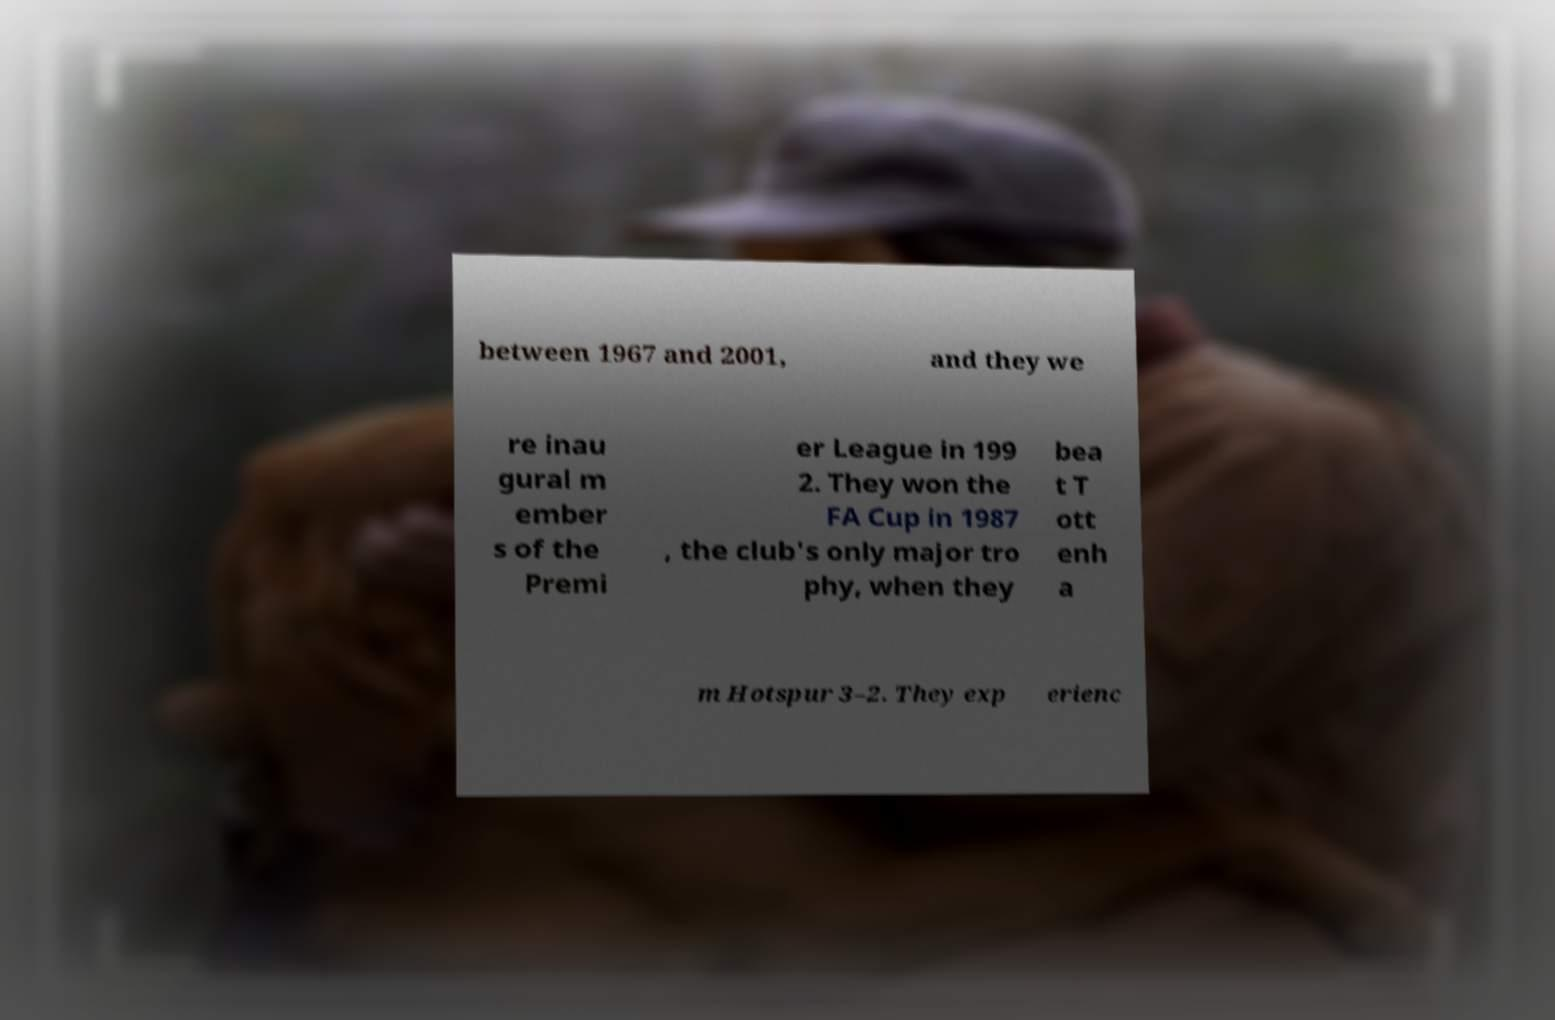There's text embedded in this image that I need extracted. Can you transcribe it verbatim? between 1967 and 2001, and they we re inau gural m ember s of the Premi er League in 199 2. They won the FA Cup in 1987 , the club's only major tro phy, when they bea t T ott enh a m Hotspur 3–2. They exp erienc 